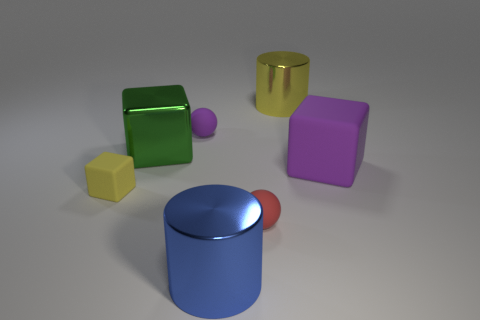There is a purple block; is it the same size as the matte cube in front of the big purple matte object?
Give a very brief answer. No. Does the yellow shiny thing have the same size as the red thing?
Provide a short and direct response. No. Is there any other thing that has the same color as the big matte object?
Keep it short and to the point. Yes. The small rubber thing that is right of the big green cube and in front of the green metal thing has what shape?
Your answer should be very brief. Sphere. There is a purple rubber block that is in front of the big yellow cylinder; what is its size?
Offer a very short reply. Large. There is a big thing in front of the tiny ball that is in front of the tiny yellow thing; what number of small cubes are to the right of it?
Give a very brief answer. 0. What material is the large thing that is both to the left of the small red rubber thing and behind the big blue metal cylinder?
Make the answer very short. Metal. Does the purple rubber object to the right of the big yellow cylinder have the same shape as the yellow thing that is to the right of the green object?
Your answer should be very brief. No. What is the shape of the yellow thing to the right of the big metallic object that is in front of the shiny object to the left of the large blue metallic cylinder?
Your answer should be very brief. Cylinder. There is a cylinder that is the same size as the blue thing; what color is it?
Give a very brief answer. Yellow. 